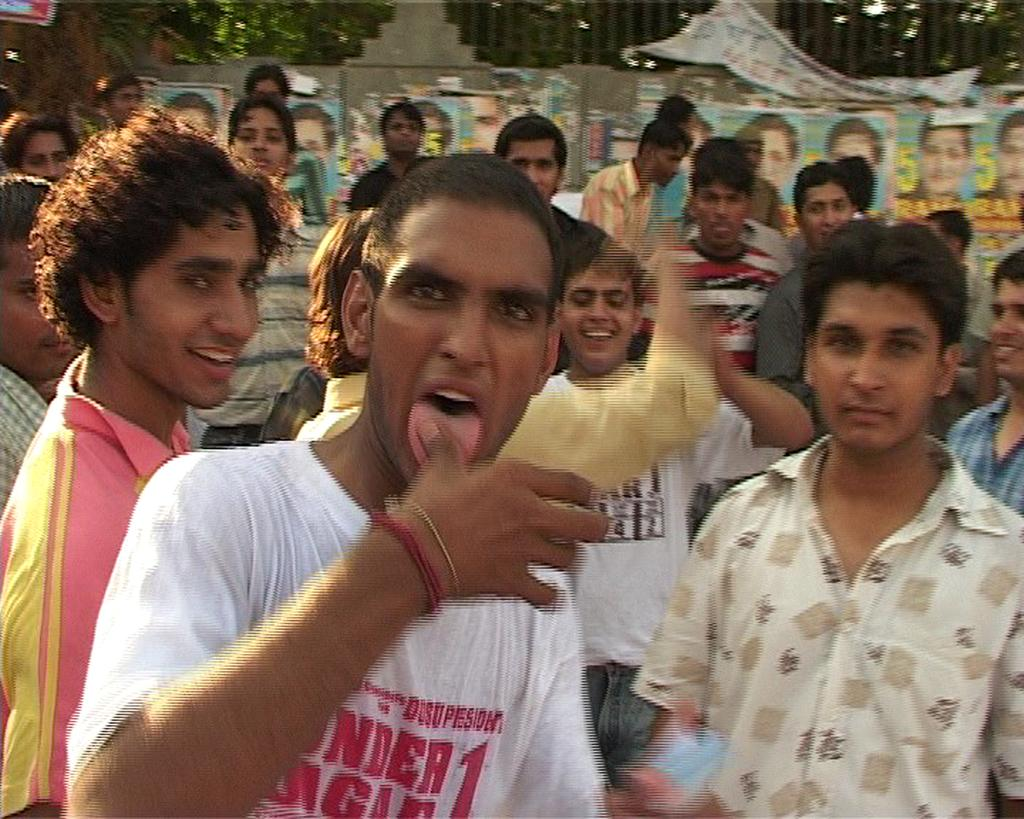How many people are present in the image? There are many people in the image. What can be seen on the wall in the image? There is a wall with posters in the image. What type of plant is near the wall in the image? There is a tree near the wall in the image. What type of amusement can be seen in the image? There is no amusement present in the image; it features a group of people, a wall with posters, and a tree. Is there any popcorn visible in the image? There is no popcorn present in the image. 